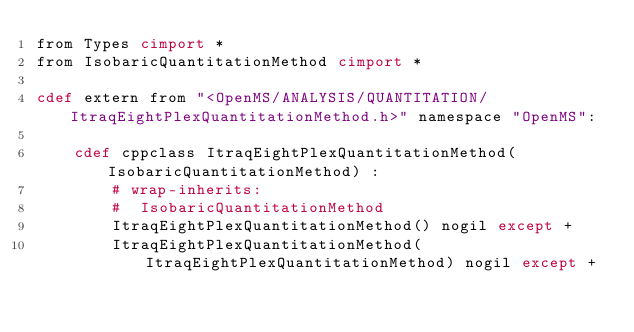<code> <loc_0><loc_0><loc_500><loc_500><_Cython_>from Types cimport *
from IsobaricQuantitationMethod cimport *

cdef extern from "<OpenMS/ANALYSIS/QUANTITATION/ItraqEightPlexQuantitationMethod.h>" namespace "OpenMS":
    
    cdef cppclass ItraqEightPlexQuantitationMethod(IsobaricQuantitationMethod) :
        # wrap-inherits:
        #  IsobaricQuantitationMethod
        ItraqEightPlexQuantitationMethod() nogil except +
        ItraqEightPlexQuantitationMethod(ItraqEightPlexQuantitationMethod) nogil except +

</code> 